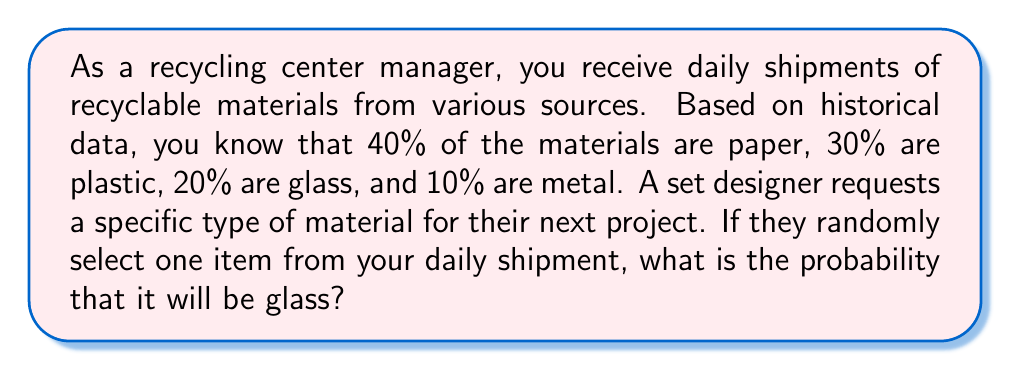Provide a solution to this math problem. To solve this problem, we need to understand the concept of probability and how it relates to the given information.

1. First, let's identify the key information:
   - The recyclable materials are divided into four categories: paper, plastic, glass, and metal.
   - The probabilities of each category are given as percentages.

2. We can represent these probabilities as fractions or decimals:
   - Paper: 40% = 0.40
   - Plastic: 30% = 0.30
   - Glass: 20% = 0.20
   - Metal: 10% = 0.10

3. The question asks specifically about the probability of selecting glass.

4. In probability theory, when we have mutually exclusive events (in this case, an item can only be one type of material) and their probabilities sum to 1 (or 100%), we can directly use the given probability for the event we're interested in.

5. The probability of selecting glass is given as 20% or 0.20.

Therefore, the probability of randomly selecting a glass item from the daily shipment is 0.20 or 20%.

We can verify that this makes sense by checking that all probabilities sum to 1:

$$ 0.40 + 0.30 + 0.20 + 0.10 = 1.00 $$

This confirms that our probability distribution is valid.
Answer: The probability of randomly selecting a glass item from the daily shipment is $0.20$ or $20\%$. 